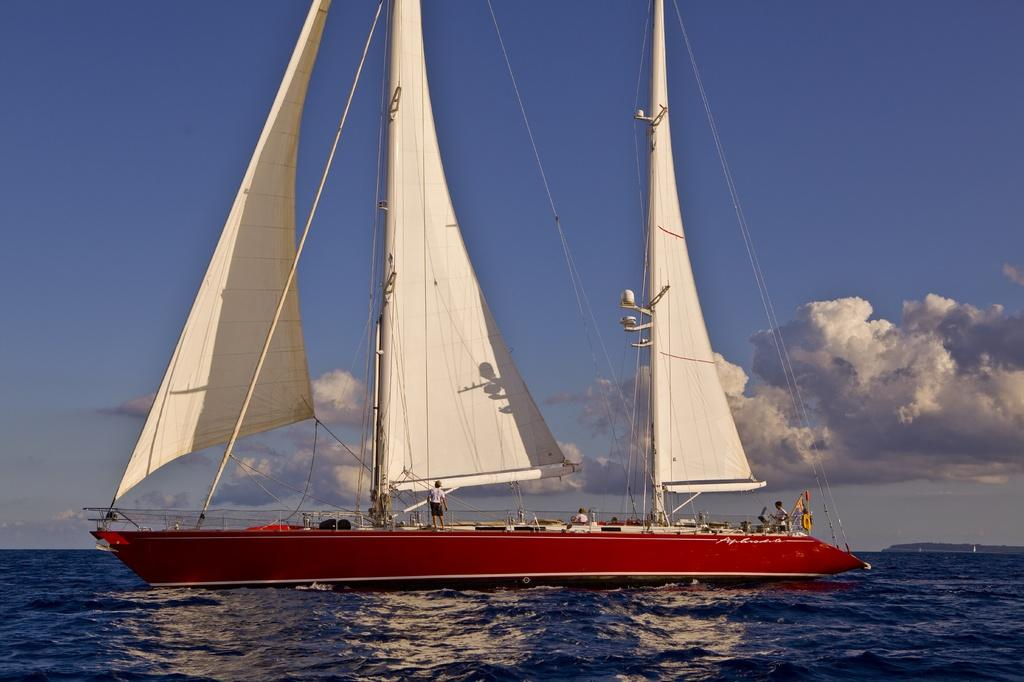What is the main subject of the image? The main subject of the image is water. What is located on the water in the image? There is a boat on the water in the image. Who or what is on the boat? There are people on the boat. What is visible at the top of the image? The sky is visible at the top of the image. How many screws can be seen holding the boat together in the image? There are no screws visible in the image; the boat appears to be a regular boat without any visible screws. 